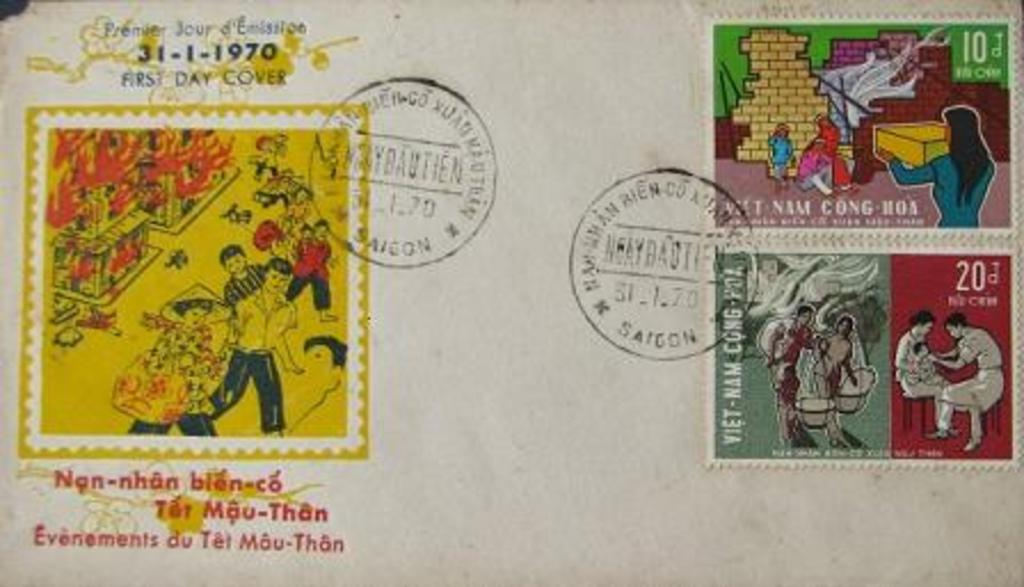What object is present in the image that might be used for sending mail? There is an envelope in the image that might be used for sending mail. What is inside the envelope? The envelope contains three different postage stamps. Is there any writing or text on the envelope? Yes, there is text on the envelope. What else can be seen on the envelope besides the text? There is a stamp on the envelope. What type of collar can be seen on the envelope in the image? There is no collar present on the envelope in the image. 